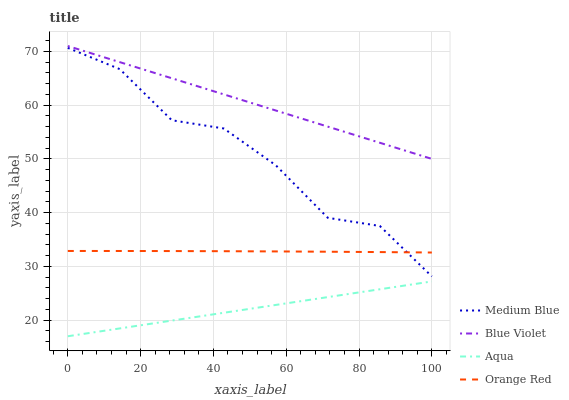Does Aqua have the minimum area under the curve?
Answer yes or no. Yes. Does Blue Violet have the maximum area under the curve?
Answer yes or no. Yes. Does Medium Blue have the minimum area under the curve?
Answer yes or no. No. Does Medium Blue have the maximum area under the curve?
Answer yes or no. No. Is Blue Violet the smoothest?
Answer yes or no. Yes. Is Medium Blue the roughest?
Answer yes or no. Yes. Is Orange Red the smoothest?
Answer yes or no. No. Is Orange Red the roughest?
Answer yes or no. No. Does Medium Blue have the lowest value?
Answer yes or no. No. Does Blue Violet have the highest value?
Answer yes or no. Yes. Does Medium Blue have the highest value?
Answer yes or no. No. Is Orange Red less than Blue Violet?
Answer yes or no. Yes. Is Orange Red greater than Aqua?
Answer yes or no. Yes. Does Orange Red intersect Medium Blue?
Answer yes or no. Yes. Is Orange Red less than Medium Blue?
Answer yes or no. No. Is Orange Red greater than Medium Blue?
Answer yes or no. No. Does Orange Red intersect Blue Violet?
Answer yes or no. No. 